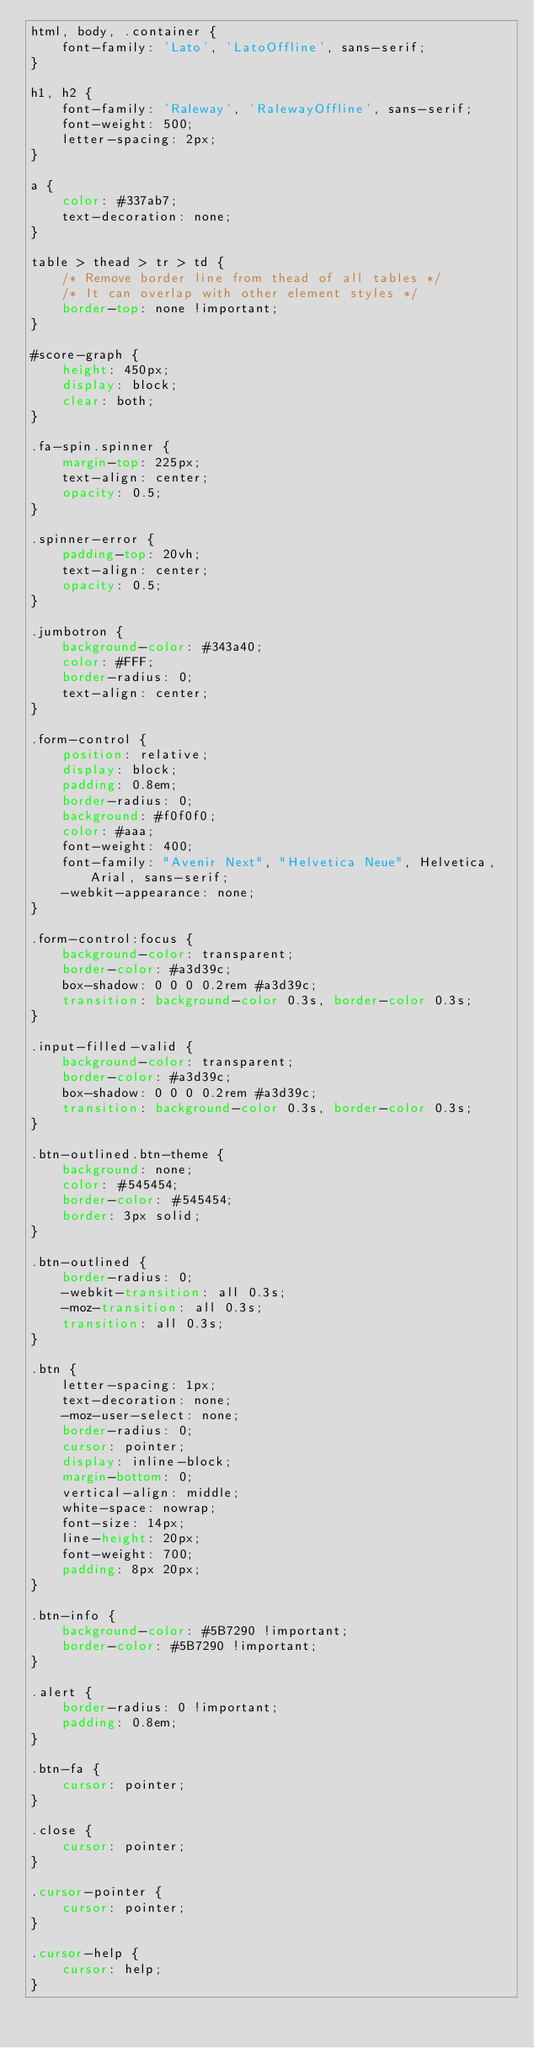<code> <loc_0><loc_0><loc_500><loc_500><_CSS_>html, body, .container {
    font-family: 'Lato', 'LatoOffline', sans-serif;
}

h1, h2 {
    font-family: 'Raleway', 'RalewayOffline', sans-serif;
    font-weight: 500;
    letter-spacing: 2px;
}

a {
    color: #337ab7;
    text-decoration: none;
}

table > thead > tr > td {
    /* Remove border line from thead of all tables */
    /* It can overlap with other element styles */
    border-top: none !important;
}

#score-graph {
    height: 450px;
    display: block;
    clear: both;
}

.fa-spin.spinner {
    margin-top: 225px;
    text-align: center;
    opacity: 0.5;
}

.spinner-error {
    padding-top: 20vh;
    text-align: center;
    opacity: 0.5;
}

.jumbotron {
    background-color: #343a40;
    color: #FFF;
    border-radius: 0;
    text-align: center;
}

.form-control {
    position: relative;
    display: block;
    padding: 0.8em;
    border-radius: 0;
    background: #f0f0f0;
    color: #aaa;
    font-weight: 400;
    font-family: "Avenir Next", "Helvetica Neue", Helvetica, Arial, sans-serif;
    -webkit-appearance: none;
}

.form-control:focus {
    background-color: transparent;
    border-color: #a3d39c;
    box-shadow: 0 0 0 0.2rem #a3d39c;
    transition: background-color 0.3s, border-color 0.3s;
}

.input-filled-valid {
    background-color: transparent;
    border-color: #a3d39c;
    box-shadow: 0 0 0 0.2rem #a3d39c;
    transition: background-color 0.3s, border-color 0.3s;
}

.btn-outlined.btn-theme {
    background: none;
    color: #545454;
    border-color: #545454;
    border: 3px solid;
}

.btn-outlined {
    border-radius: 0;
    -webkit-transition: all 0.3s;
    -moz-transition: all 0.3s;
    transition: all 0.3s;
}

.btn {
    letter-spacing: 1px;
    text-decoration: none;
    -moz-user-select: none;
    border-radius: 0;
    cursor: pointer;
    display: inline-block;
    margin-bottom: 0;
    vertical-align: middle;
    white-space: nowrap;
    font-size: 14px;
    line-height: 20px;
    font-weight: 700;
    padding: 8px 20px;
}

.btn-info {
    background-color: #5B7290 !important;
    border-color: #5B7290 !important;
}

.alert {
    border-radius: 0 !important;
    padding: 0.8em;
}

.btn-fa {
    cursor: pointer;
}

.close {
    cursor: pointer;
}

.cursor-pointer {
    cursor: pointer;
}

.cursor-help {
    cursor: help;
}</code> 